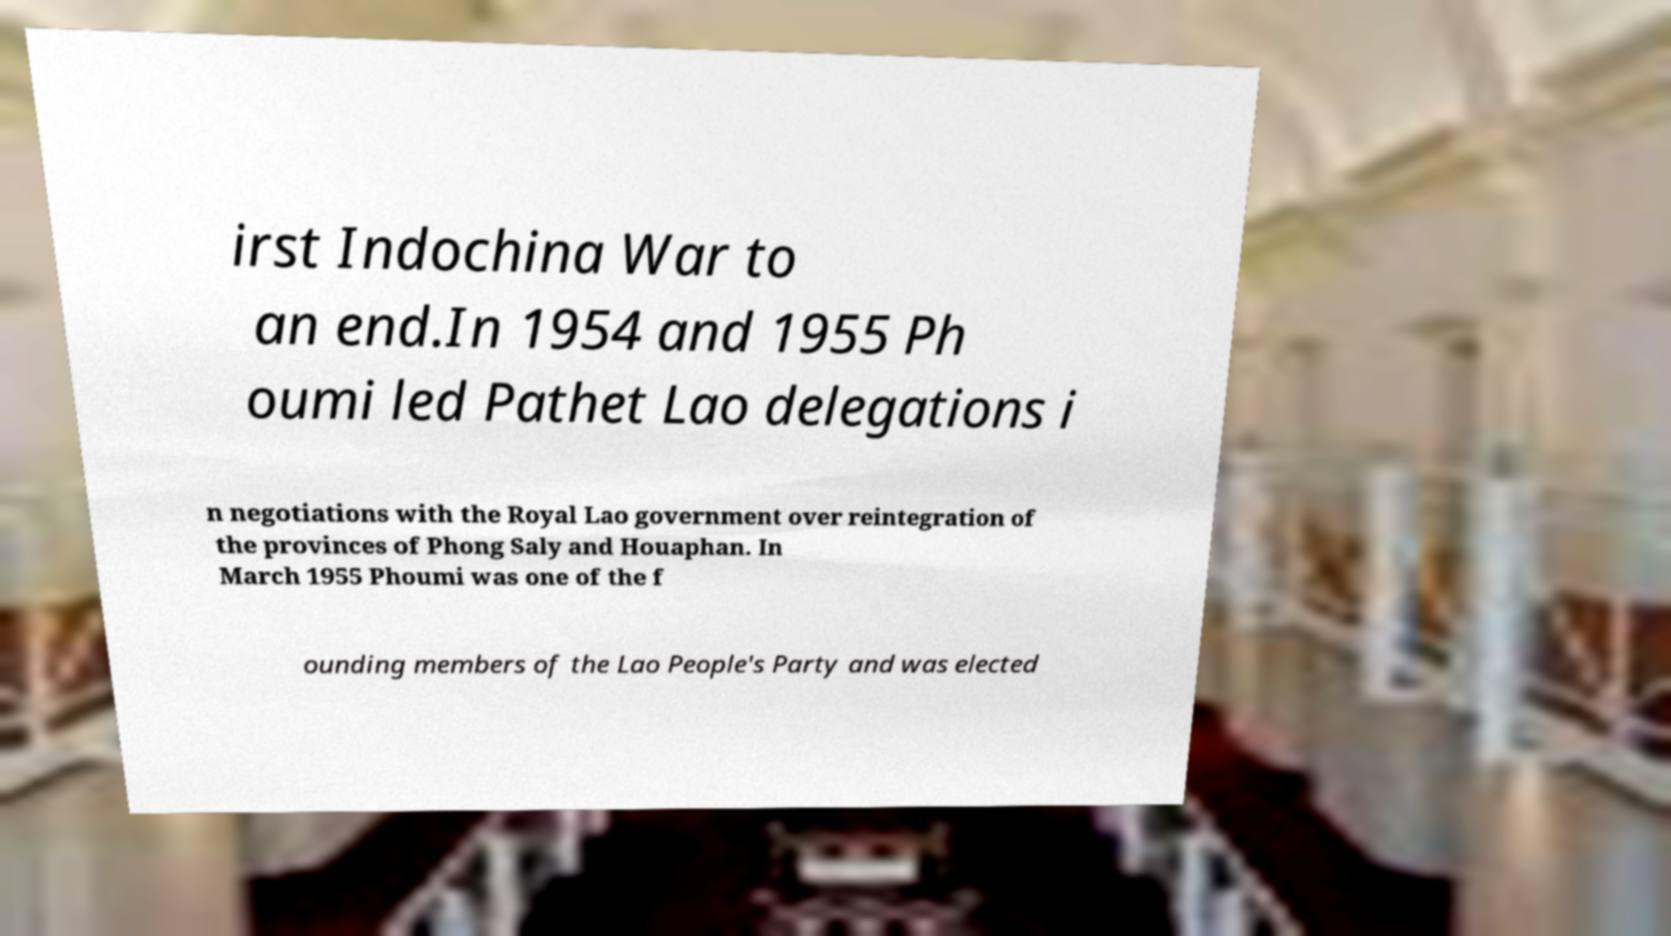Could you extract and type out the text from this image? irst Indochina War to an end.In 1954 and 1955 Ph oumi led Pathet Lao delegations i n negotiations with the Royal Lao government over reintegration of the provinces of Phong Saly and Houaphan. In March 1955 Phoumi was one of the f ounding members of the Lao People's Party and was elected 